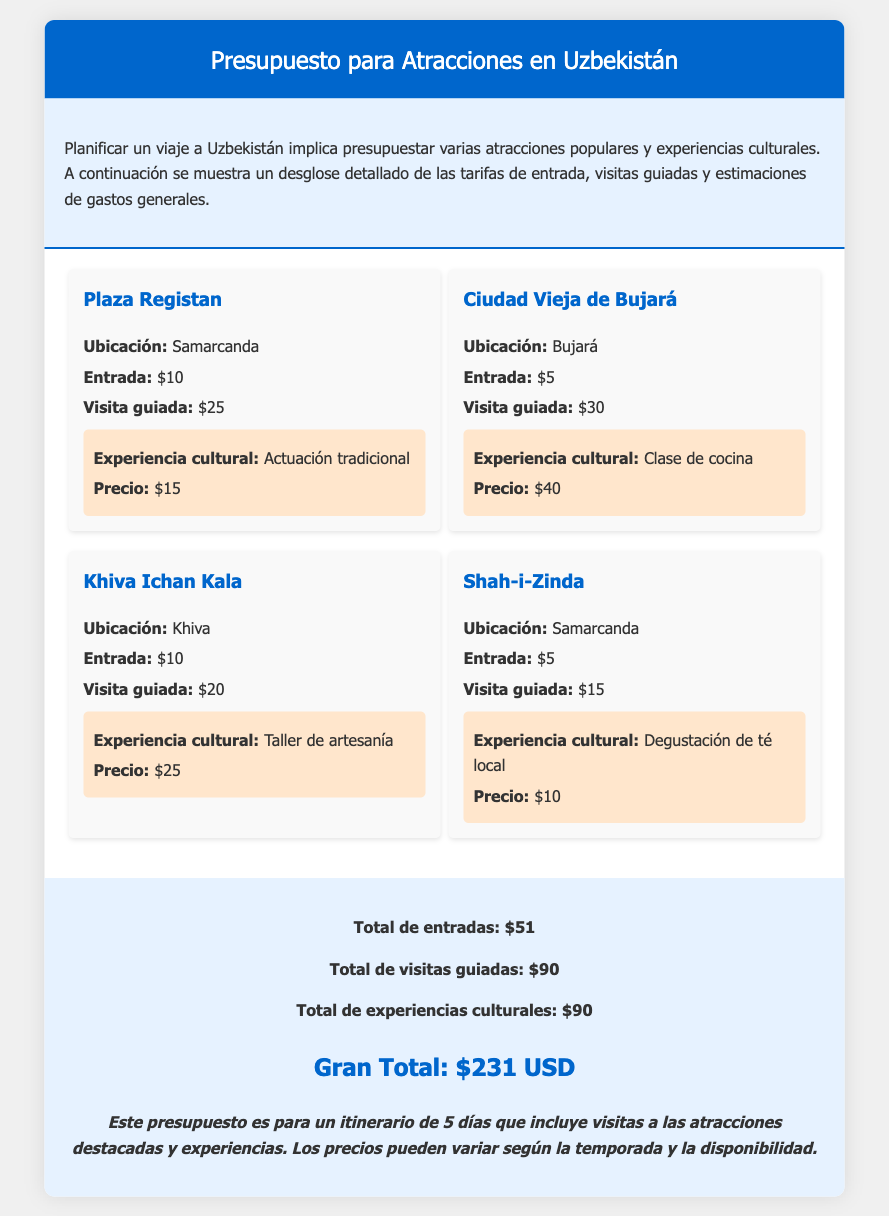¿Cuál es el precio de entrada para la Plaza Registan? La entrada para la Plaza Registan es de $10.
Answer: $10 ¿Cuánto cuesta una visita guiada en la Ciudad Vieja de Bujará? La visita guiada en la Ciudad Vieja de Bujará cuesta $30.
Answer: $30 ¿Qué cultura se experimenta en Khiva Ichan Kala? La experiencia cultural en Khiva Ichan Kala es un taller de artesanía.
Answer: Taller de artesanía ¿Cuál es el total de entradas para todas las atracciones? El total de entradas es la suma de todas las tarifas de entrada, que es $51.
Answer: $51 ¿Qué es la experiencia cultural en Shah-i-Zinda? La experiencia cultural en Shah-i-Zinda es una degustación de té local.
Answer: Degustación de té local ¿Cuál es el gran total del presupuesto? El gran total del presupuesto suma todas las categorías, que es $231 USD.
Answer: $231 USD ¿Cuánto se gasta en experiencias culturales en total? El total de experiencias culturales es $90.
Answer: $90 ¿En qué ciudad se encuentra la Plaza Registan? La Plaza Registan se encuentra en Samarcanda.
Answer: Samarcanda 